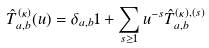Convert formula to latex. <formula><loc_0><loc_0><loc_500><loc_500>\hat { T } ^ { ( \kappa ) } _ { a , b } ( u ) = \delta _ { a , b } 1 + \sum _ { s \geq 1 } u ^ { - s } \hat { T } _ { a , b } ^ { ( \kappa ) , ( s ) }</formula> 